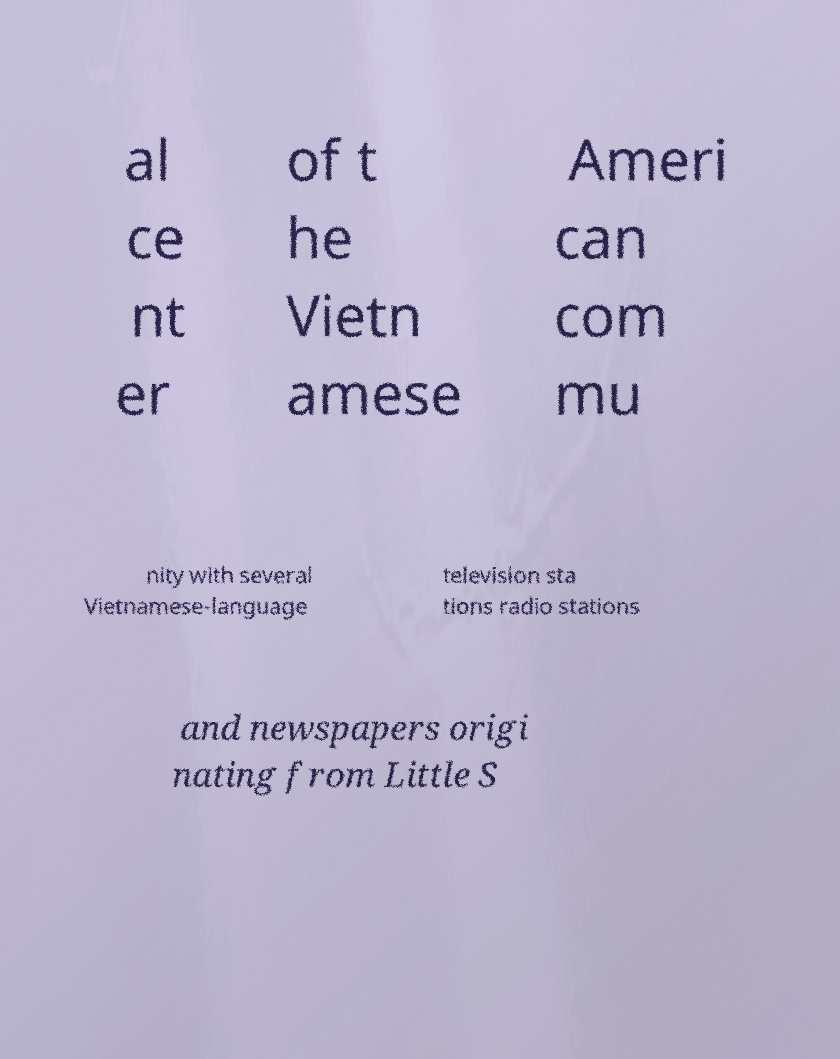Could you assist in decoding the text presented in this image and type it out clearly? al ce nt er of t he Vietn amese Ameri can com mu nity with several Vietnamese-language television sta tions radio stations and newspapers origi nating from Little S 